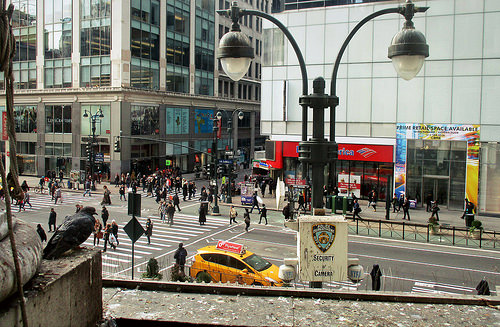<image>
Can you confirm if the car is behind the light? Yes. From this viewpoint, the car is positioned behind the light, with the light partially or fully occluding the car. Is the light to the right of the crowd? Yes. From this viewpoint, the light is positioned to the right side relative to the crowd. 